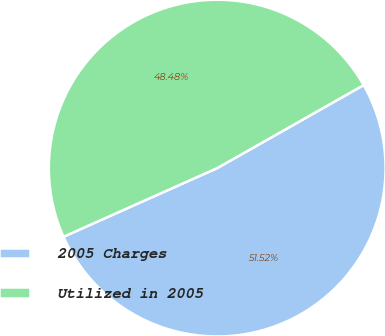Convert chart. <chart><loc_0><loc_0><loc_500><loc_500><pie_chart><fcel>2005 Charges<fcel>Utilized in 2005<nl><fcel>51.52%<fcel>48.48%<nl></chart> 